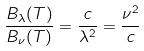<formula> <loc_0><loc_0><loc_500><loc_500>\frac { B _ { \lambda } ( T ) } { B _ { \nu } ( T ) } = \frac { c } { \lambda ^ { 2 } } = \frac { \nu ^ { 2 } } { c }</formula> 